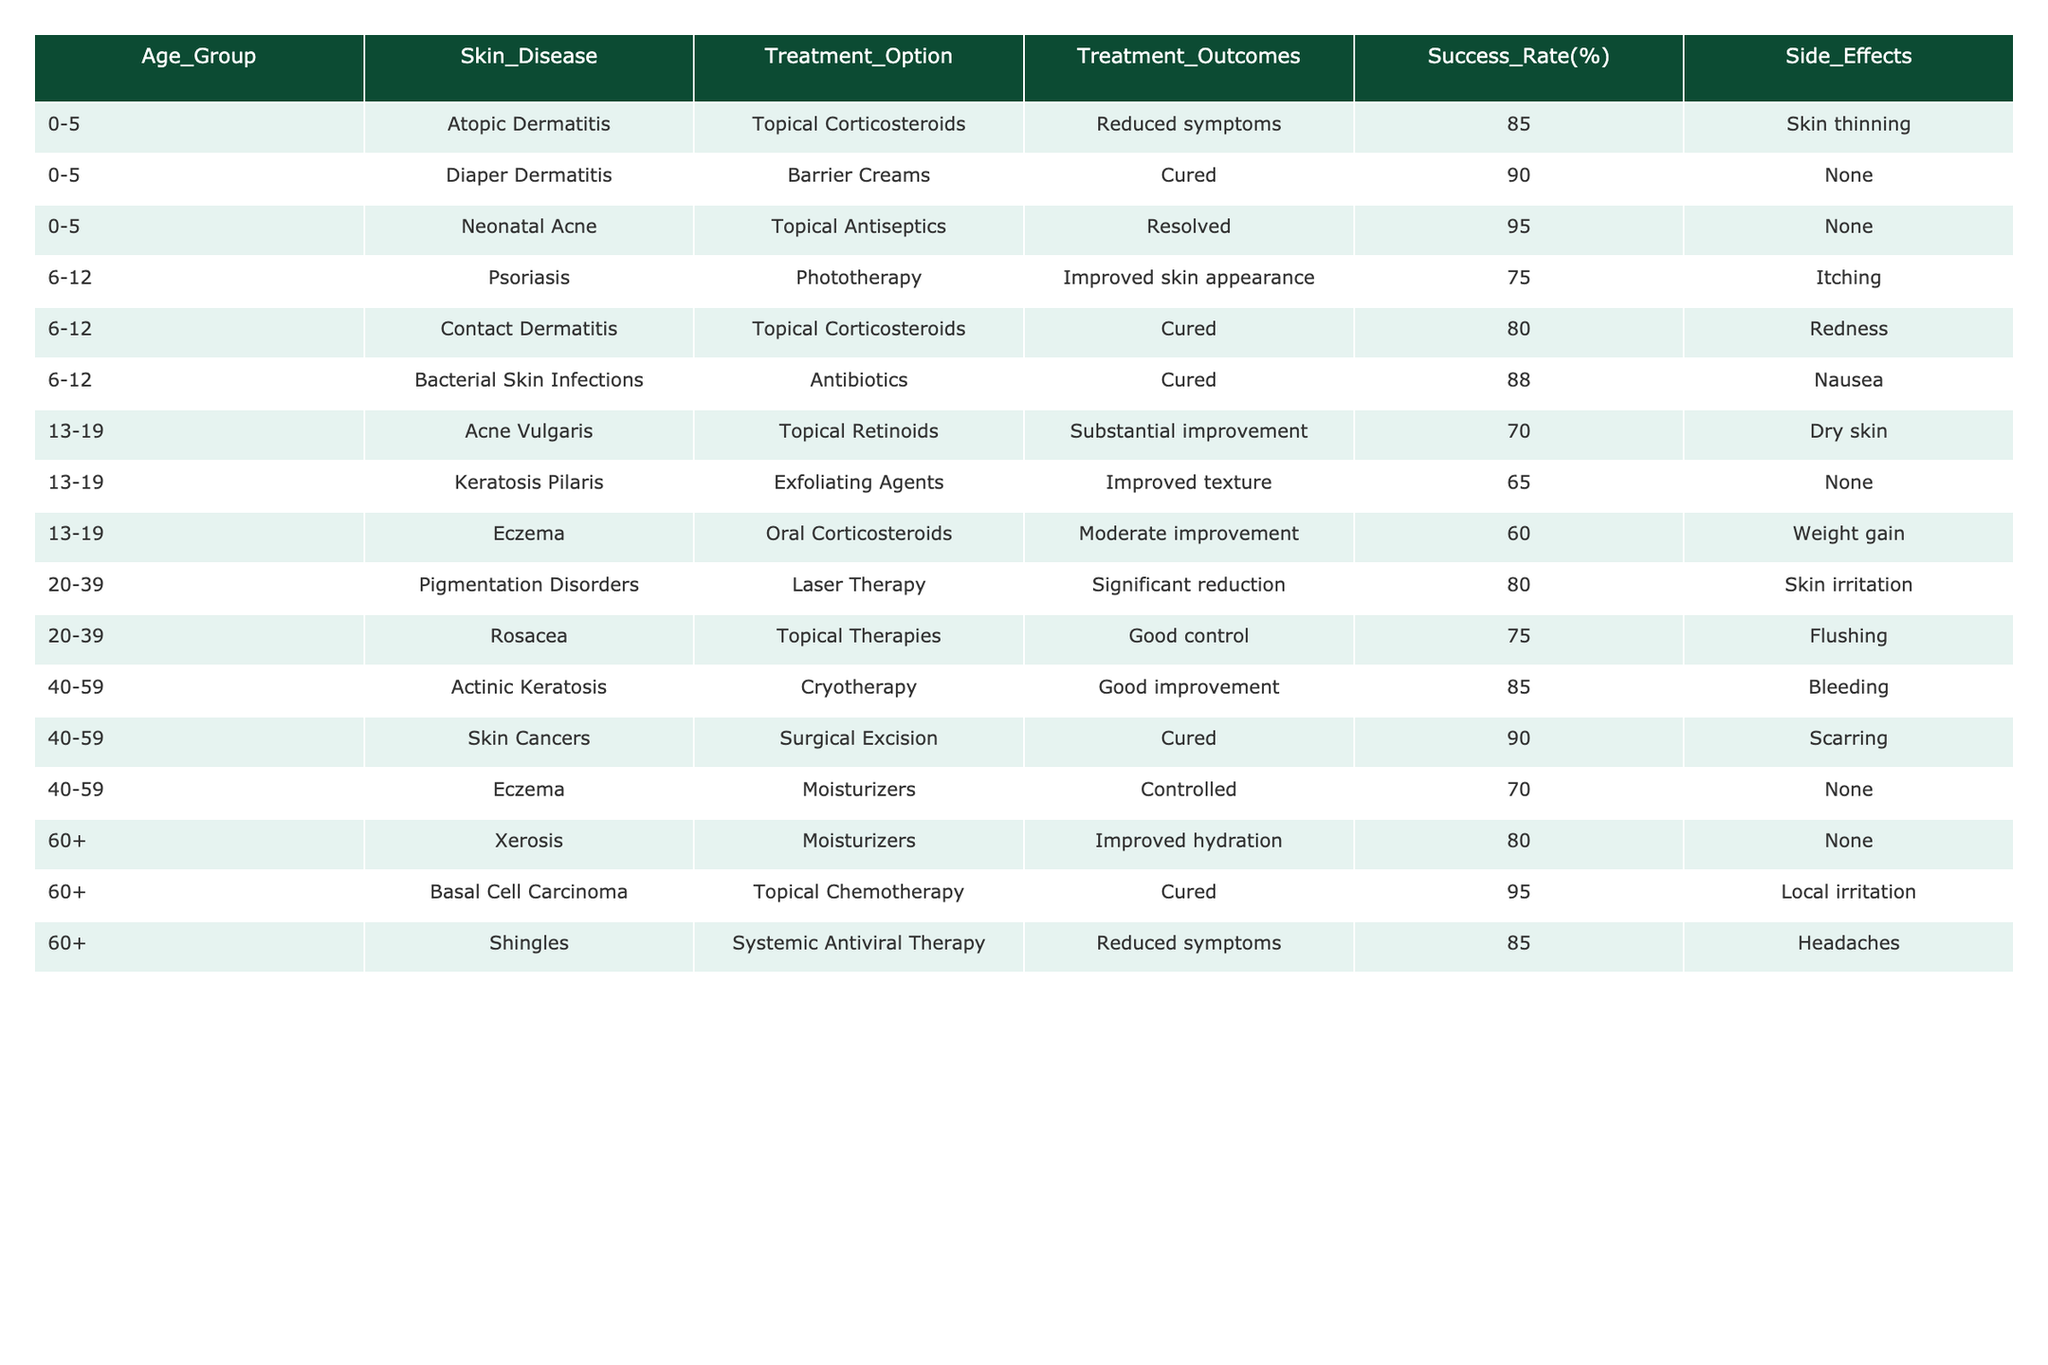What is the success rate of using topical corticosteroids for treating atopic dermatitis in children aged 0-5? The table shows that the success rate for topical corticosteroids in treating atopic dermatitis for the 0-5 age group is 85%.
Answer: 85% Which treatment option has the highest success rate for neonatal acne? The success rate for neonatal acne treated with topical antiseptics is 95%, which is the highest among the listed options.
Answer: 95% Are there any side effects reported for the treatment of diaper dermatitis? The data states that there are no side effects reported for the barrier creams used to treat diaper dermatitis.
Answer: No What is the difference in success rates between the treatment of eczema in the 13-19 age group and the 40-59 age group? The success rate for eczema in the 13-19 age group is 60%, while in the 40-59 age group it’s 70%. The difference is 70 - 60 = 10%.
Answer: 10% In the age group 20-39, what is the average success rate of treatments for pigmentation disorders and rosacea? The success rate for pigmentation disorders is 80% and for rosacea it is 75%. The average is (80 + 75) / 2 = 77.5%.
Answer: 77.5% Which skin disease in the 6-12 age group has the highest success rate with its treatment option? The bacterial skin infections treated with antibiotics have a success rate of 88%, which is the highest in that age group.
Answer: 88% Is there a treatment for basal cell carcinoma and what is its success rate? Yes, topical chemotherapy is used for basal cell carcinoma with a success rate of 95%.
Answer: Yes, 95% What is the success rate for the treatment of psoriasis compared to the treatment of contact dermatitis in the 6-12 age group? Psoriasis has a success rate of 75%, while contact dermatitis has a success rate of 80%. Therefore, contact dermatitis is more successful by 5%.
Answer: Contact dermatitis is more successful by 5% How many treatments listed have a success rate of 90% or higher? There are three treatments with a success rate of 90% or higher: diaper dermatitis (90%), neonatal acne (95%), and skin cancers (90%). That makes a total of three.
Answer: 3 What is the relationship between the success rate and side effects for the treatments provided for age group 60+? The success rates for treatments in the 60+ age group are all 80% or higher, but two of the treatments (for xerosis and shingles) have no side effects, while the one for basal cell carcinoma has local irritation. The outcomes suggest a correlation where higher success rates are associated with minimal or manageable side effects.
Answer: Higher success rates typically correlate with fewer side effects 